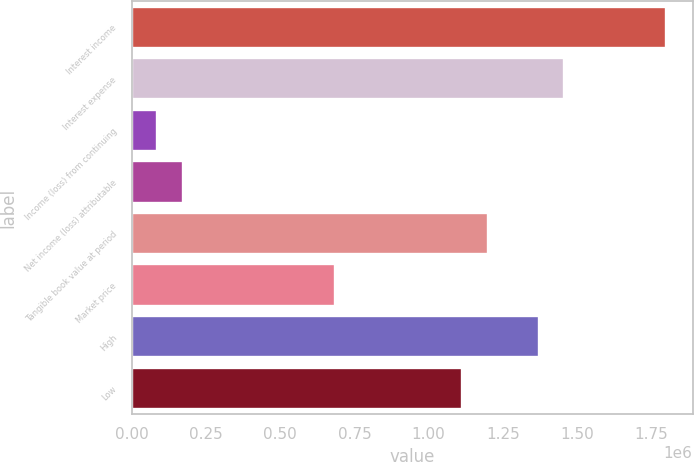<chart> <loc_0><loc_0><loc_500><loc_500><bar_chart><fcel>Interest income<fcel>Interest expense<fcel>Income (loss) from continuing<fcel>Net income (loss) attributable<fcel>Tangible book value at period<fcel>Market price<fcel>High<fcel>Low<nl><fcel>1.79996e+06<fcel>1.45711e+06<fcel>85712.4<fcel>171425<fcel>1.19997e+06<fcel>685698<fcel>1.37139e+06<fcel>1.11426e+06<nl></chart> 